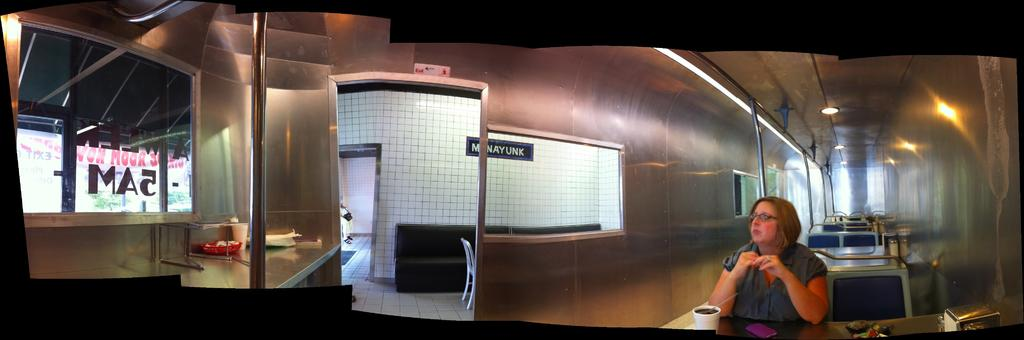What is the woman in the image doing? The woman is seated on a chair in the image. What is in front of the woman? There is a box in front of the woman. What else can be seen on the table in front of the woman? There are other things on the table in front of the woman. What can be seen in the background of the image? There are metal rods and lights in the background of the image. What type of suit is the kitty wearing in the image? There is no kitty present in the image, and therefore no suit can be observed. 